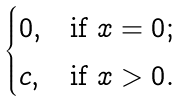<formula> <loc_0><loc_0><loc_500><loc_500>\begin{cases} 0 , & \text {if $x=0$} ; \\ c , & \text {if $x>0$} . \end{cases}</formula> 